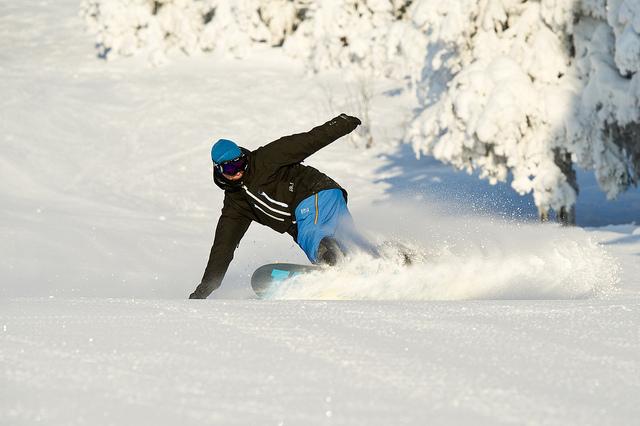Has there been a light or heavy snowfall?
Concise answer only. Heavy. Which foot does the person have forward?
Give a very brief answer. Left. Did he hurt himself?
Keep it brief. No. 